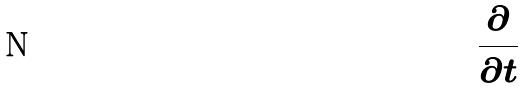<formula> <loc_0><loc_0><loc_500><loc_500>\frac { \partial } { \partial t }</formula> 